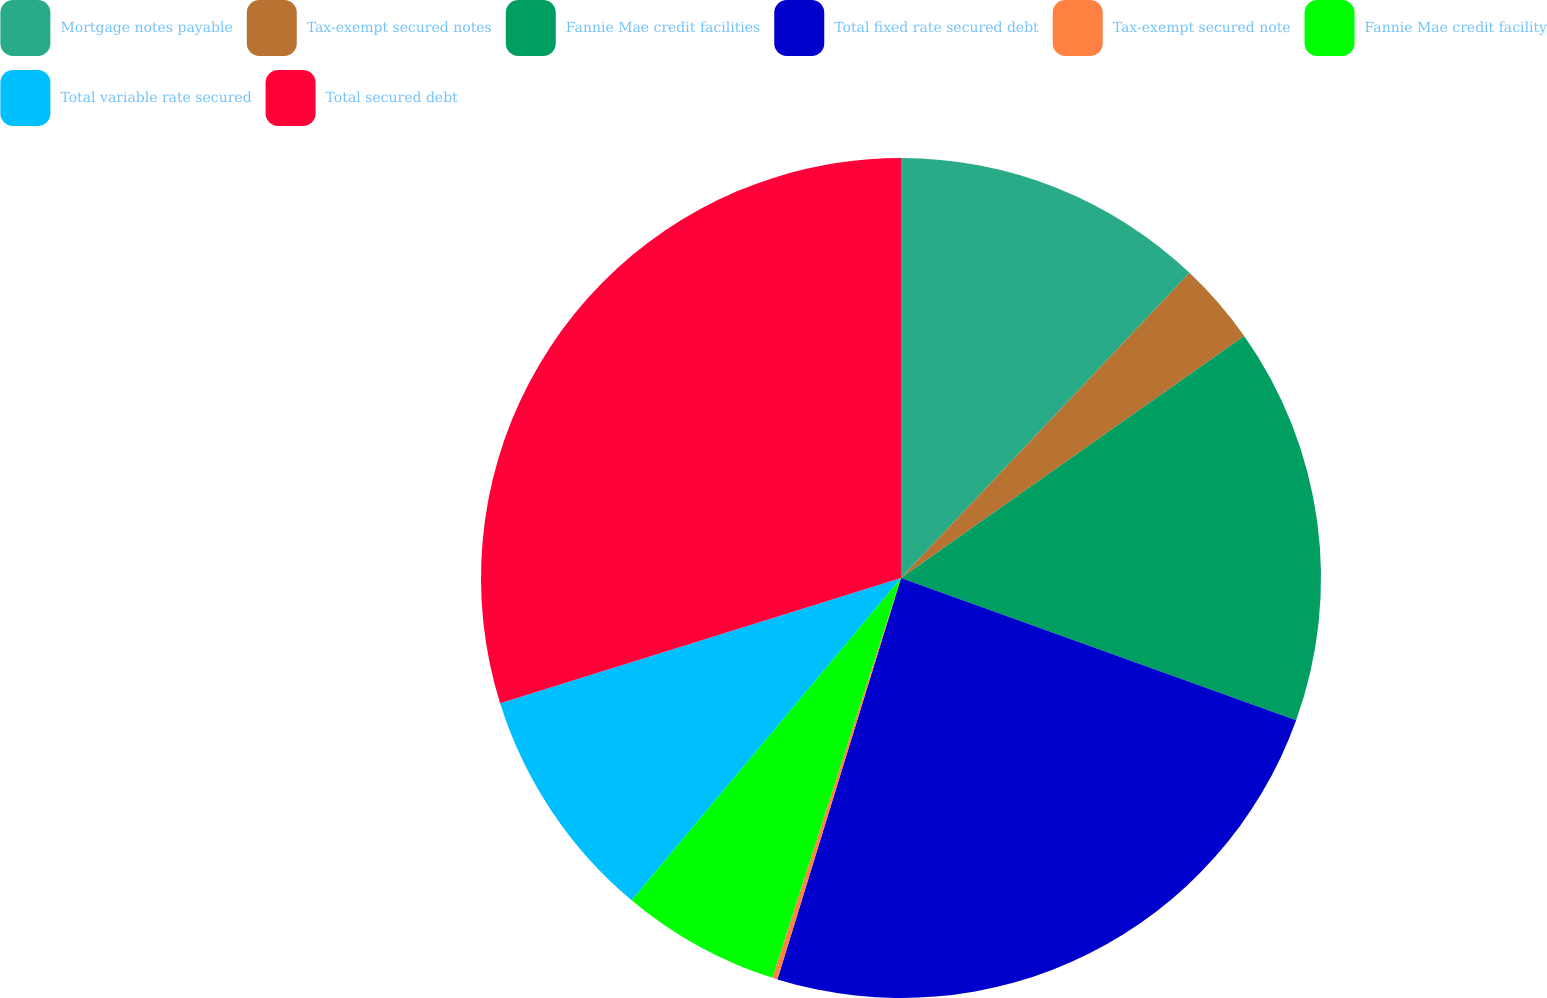Convert chart. <chart><loc_0><loc_0><loc_500><loc_500><pie_chart><fcel>Mortgage notes payable<fcel>Tax-exempt secured notes<fcel>Fannie Mae credit facilities<fcel>Total fixed rate secured debt<fcel>Tax-exempt secured note<fcel>Fannie Mae credit facility<fcel>Total variable rate secured<fcel>Total secured debt<nl><fcel>12.05%<fcel>3.17%<fcel>15.28%<fcel>24.25%<fcel>0.2%<fcel>6.13%<fcel>9.09%<fcel>29.82%<nl></chart> 